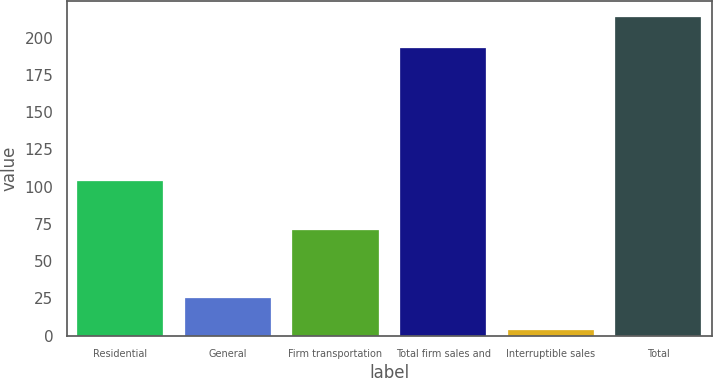Convert chart to OTSL. <chart><loc_0><loc_0><loc_500><loc_500><bar_chart><fcel>Residential<fcel>General<fcel>Firm transportation<fcel>Total firm sales and<fcel>Interruptible sales<fcel>Total<nl><fcel>104<fcel>25<fcel>71<fcel>193<fcel>4<fcel>214<nl></chart> 